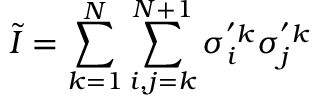Convert formula to latex. <formula><loc_0><loc_0><loc_500><loc_500>\tilde { I } = \sum _ { k = 1 } ^ { N } { \sum _ { i , j = k } ^ { N + 1 } { \sigma _ { i } ^ { ^ { \prime } k } \sigma _ { j } ^ { ^ { \prime } k } } }</formula> 